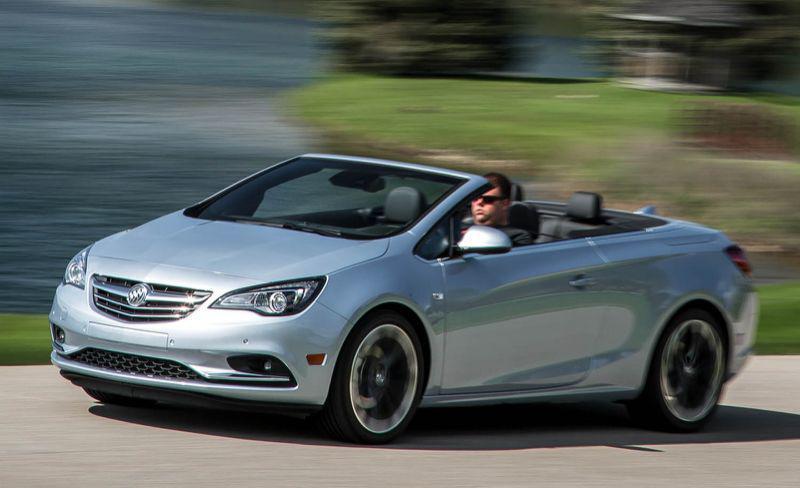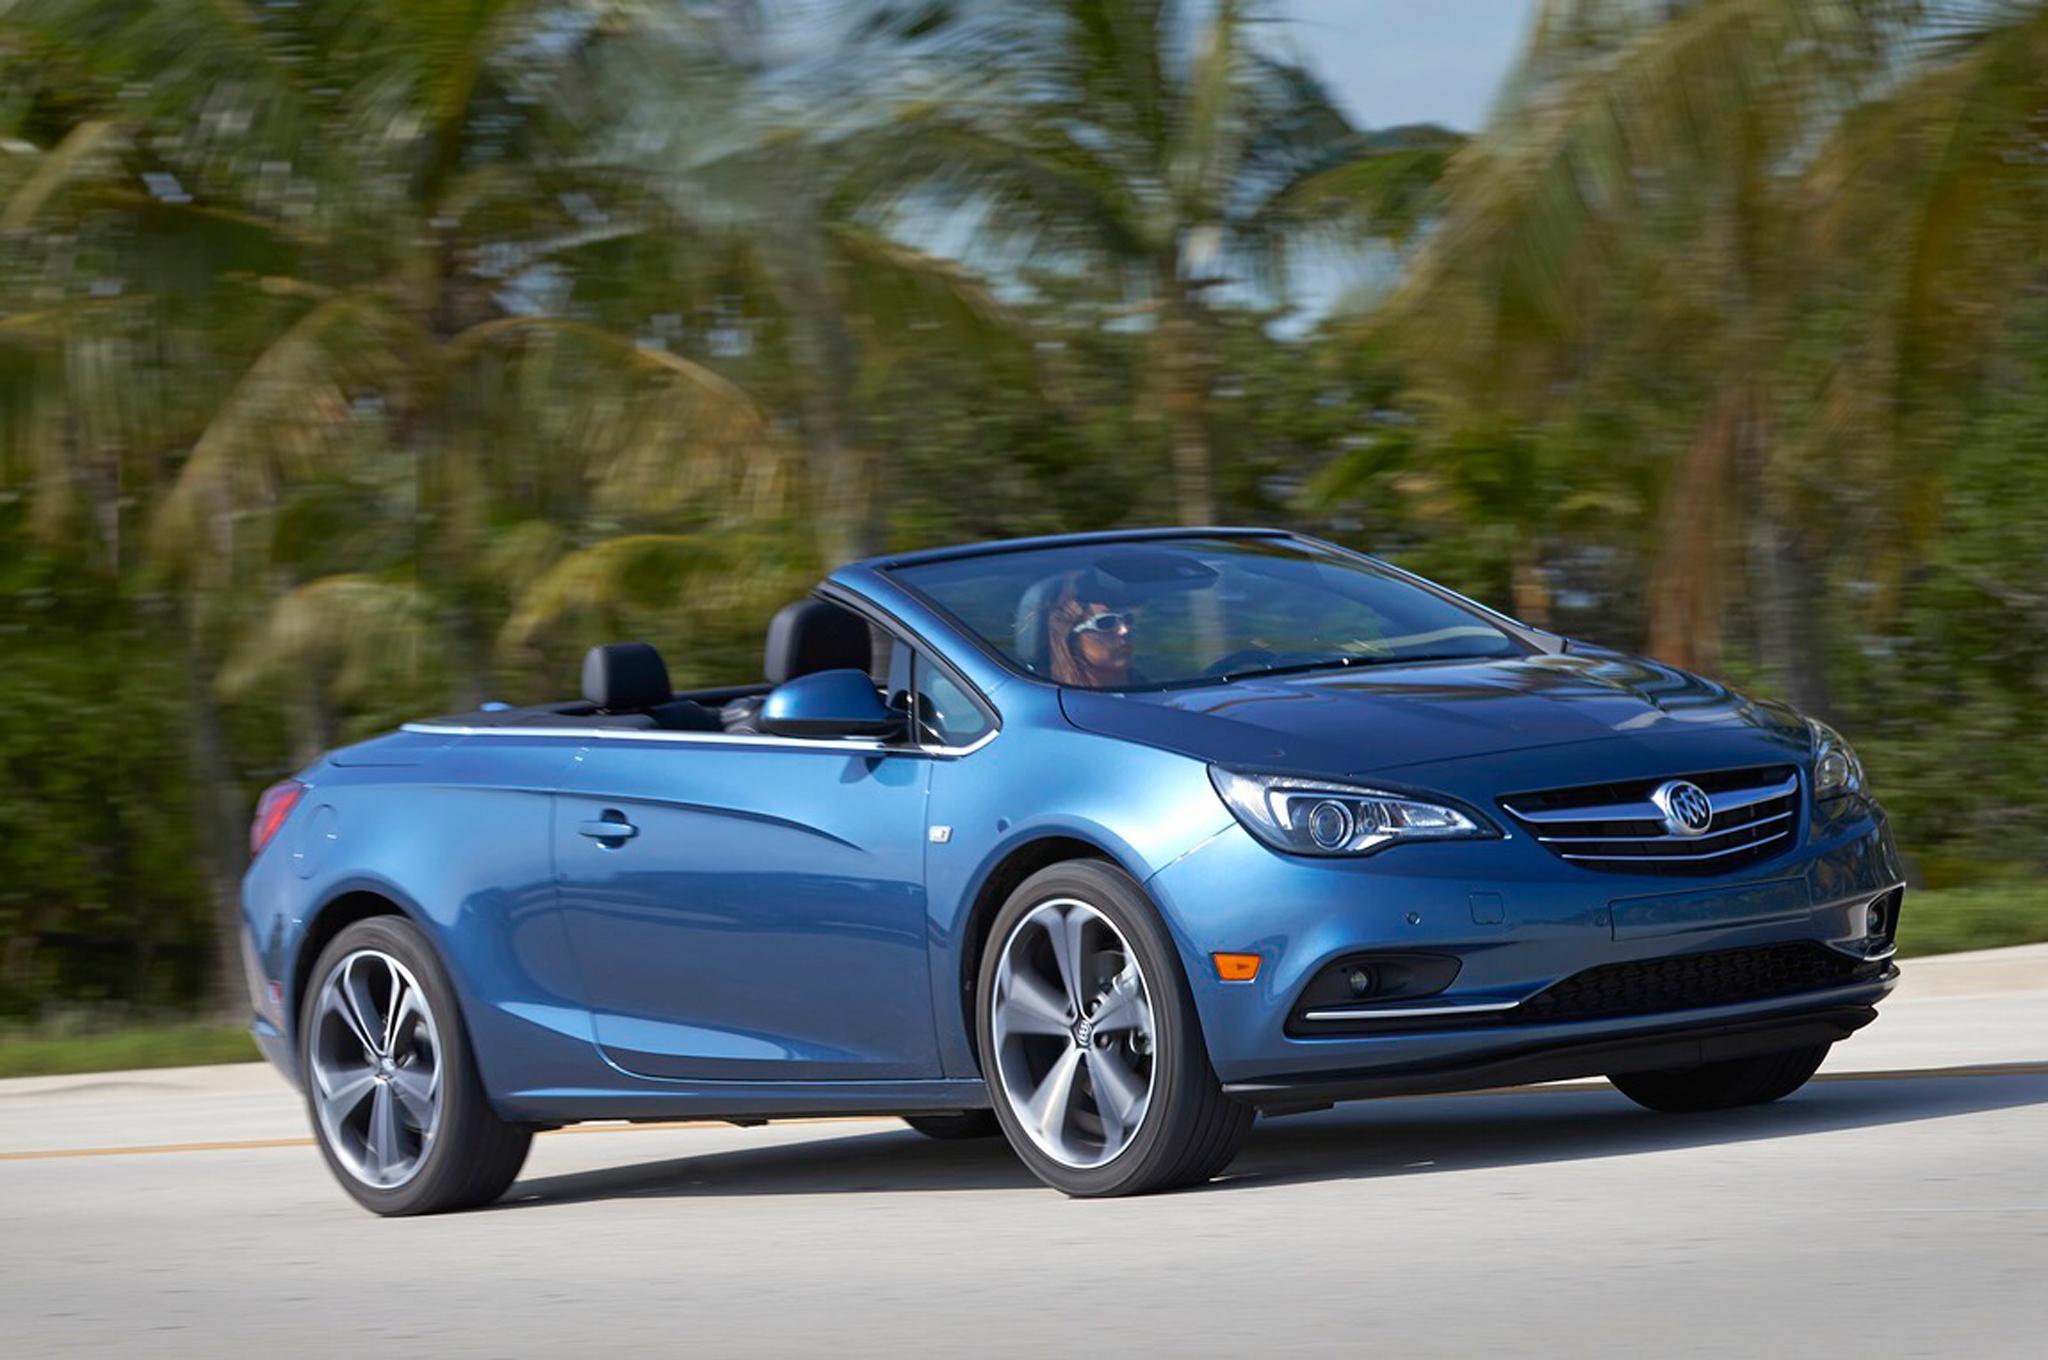The first image is the image on the left, the second image is the image on the right. For the images displayed, is the sentence "The left image contains a convertible that is facing towards the left." factually correct? Answer yes or no. Yes. The first image is the image on the left, the second image is the image on the right. Given the left and right images, does the statement "One image shows a forward-angled medium-blue convertible with a windshield that slopes to the hood." hold true? Answer yes or no. Yes. 